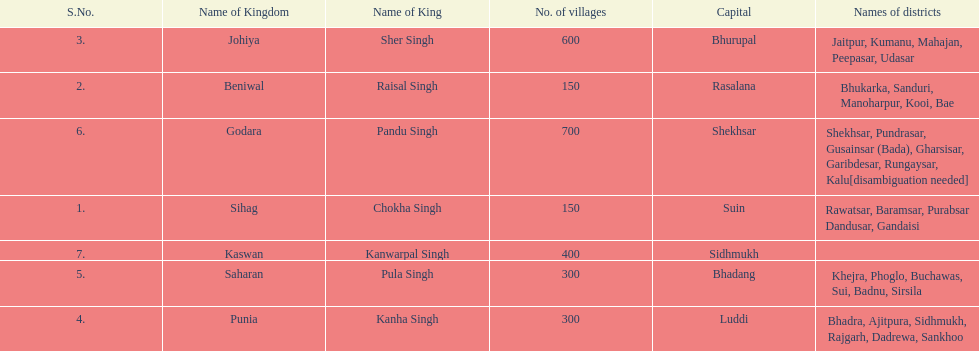How many districts does punia have? 6. 